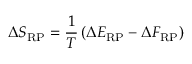<formula> <loc_0><loc_0><loc_500><loc_500>\Delta S _ { R P } = \frac { 1 } { T } \left ( \Delta E _ { R P } - \Delta F _ { R P } \right )</formula> 